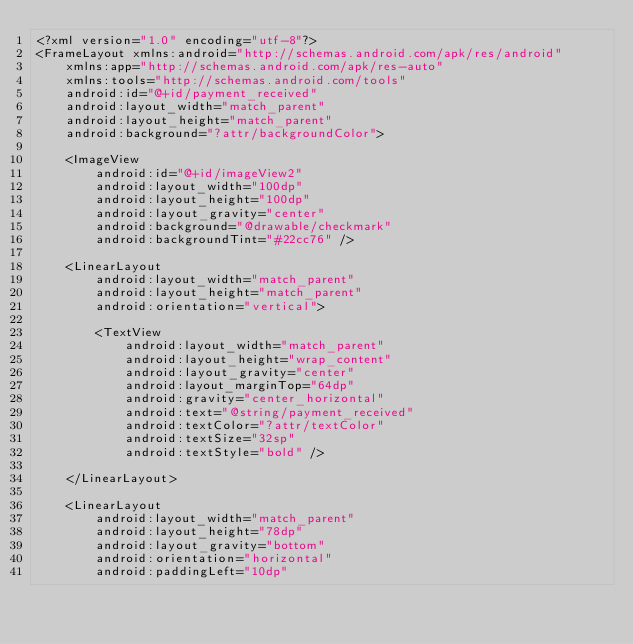Convert code to text. <code><loc_0><loc_0><loc_500><loc_500><_XML_><?xml version="1.0" encoding="utf-8"?>
<FrameLayout xmlns:android="http://schemas.android.com/apk/res/android"
    xmlns:app="http://schemas.android.com/apk/res-auto"
    xmlns:tools="http://schemas.android.com/tools"
    android:id="@+id/payment_received"
    android:layout_width="match_parent"
    android:layout_height="match_parent"
    android:background="?attr/backgroundColor">

    <ImageView
        android:id="@+id/imageView2"
        android:layout_width="100dp"
        android:layout_height="100dp"
        android:layout_gravity="center"
        android:background="@drawable/checkmark"
        android:backgroundTint="#22cc76" />

    <LinearLayout
        android:layout_width="match_parent"
        android:layout_height="match_parent"
        android:orientation="vertical">

        <TextView
            android:layout_width="match_parent"
            android:layout_height="wrap_content"
            android:layout_gravity="center"
            android:layout_marginTop="64dp"
            android:gravity="center_horizontal"
            android:text="@string/payment_received"
            android:textColor="?attr/textColor"
            android:textSize="32sp"
            android:textStyle="bold" />

    </LinearLayout>

    <LinearLayout
        android:layout_width="match_parent"
        android:layout_height="78dp"
        android:layout_gravity="bottom"
        android:orientation="horizontal"
        android:paddingLeft="10dp"</code> 